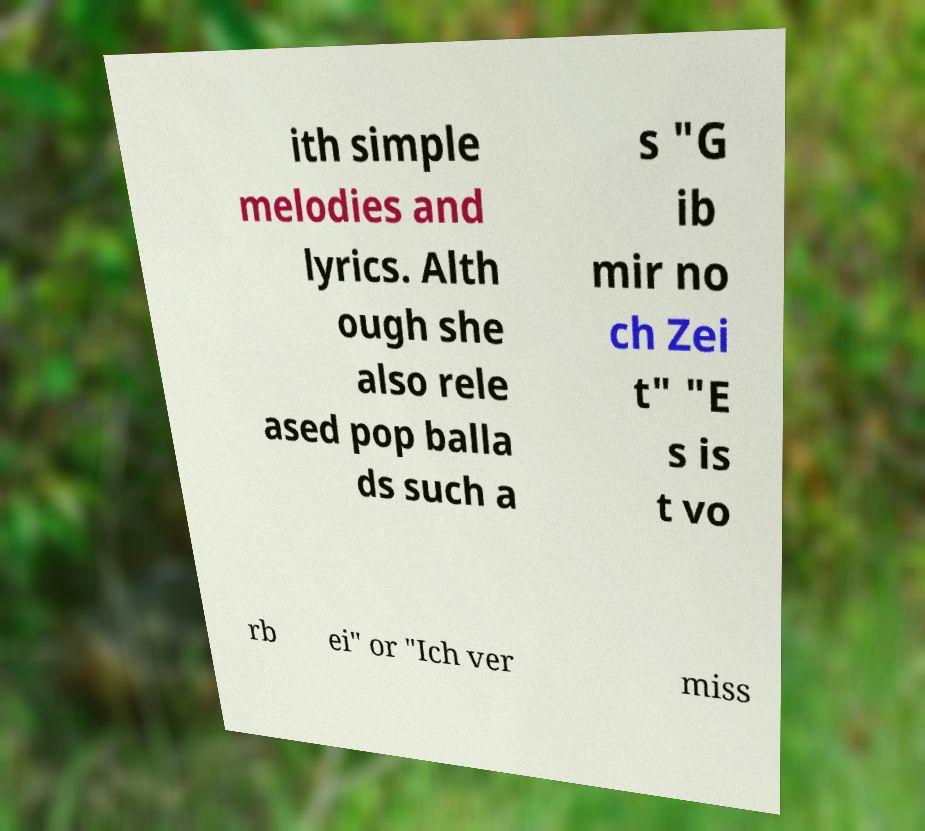There's text embedded in this image that I need extracted. Can you transcribe it verbatim? ith simple melodies and lyrics. Alth ough she also rele ased pop balla ds such a s "G ib mir no ch Zei t" "E s is t vo rb ei" or "Ich ver miss 